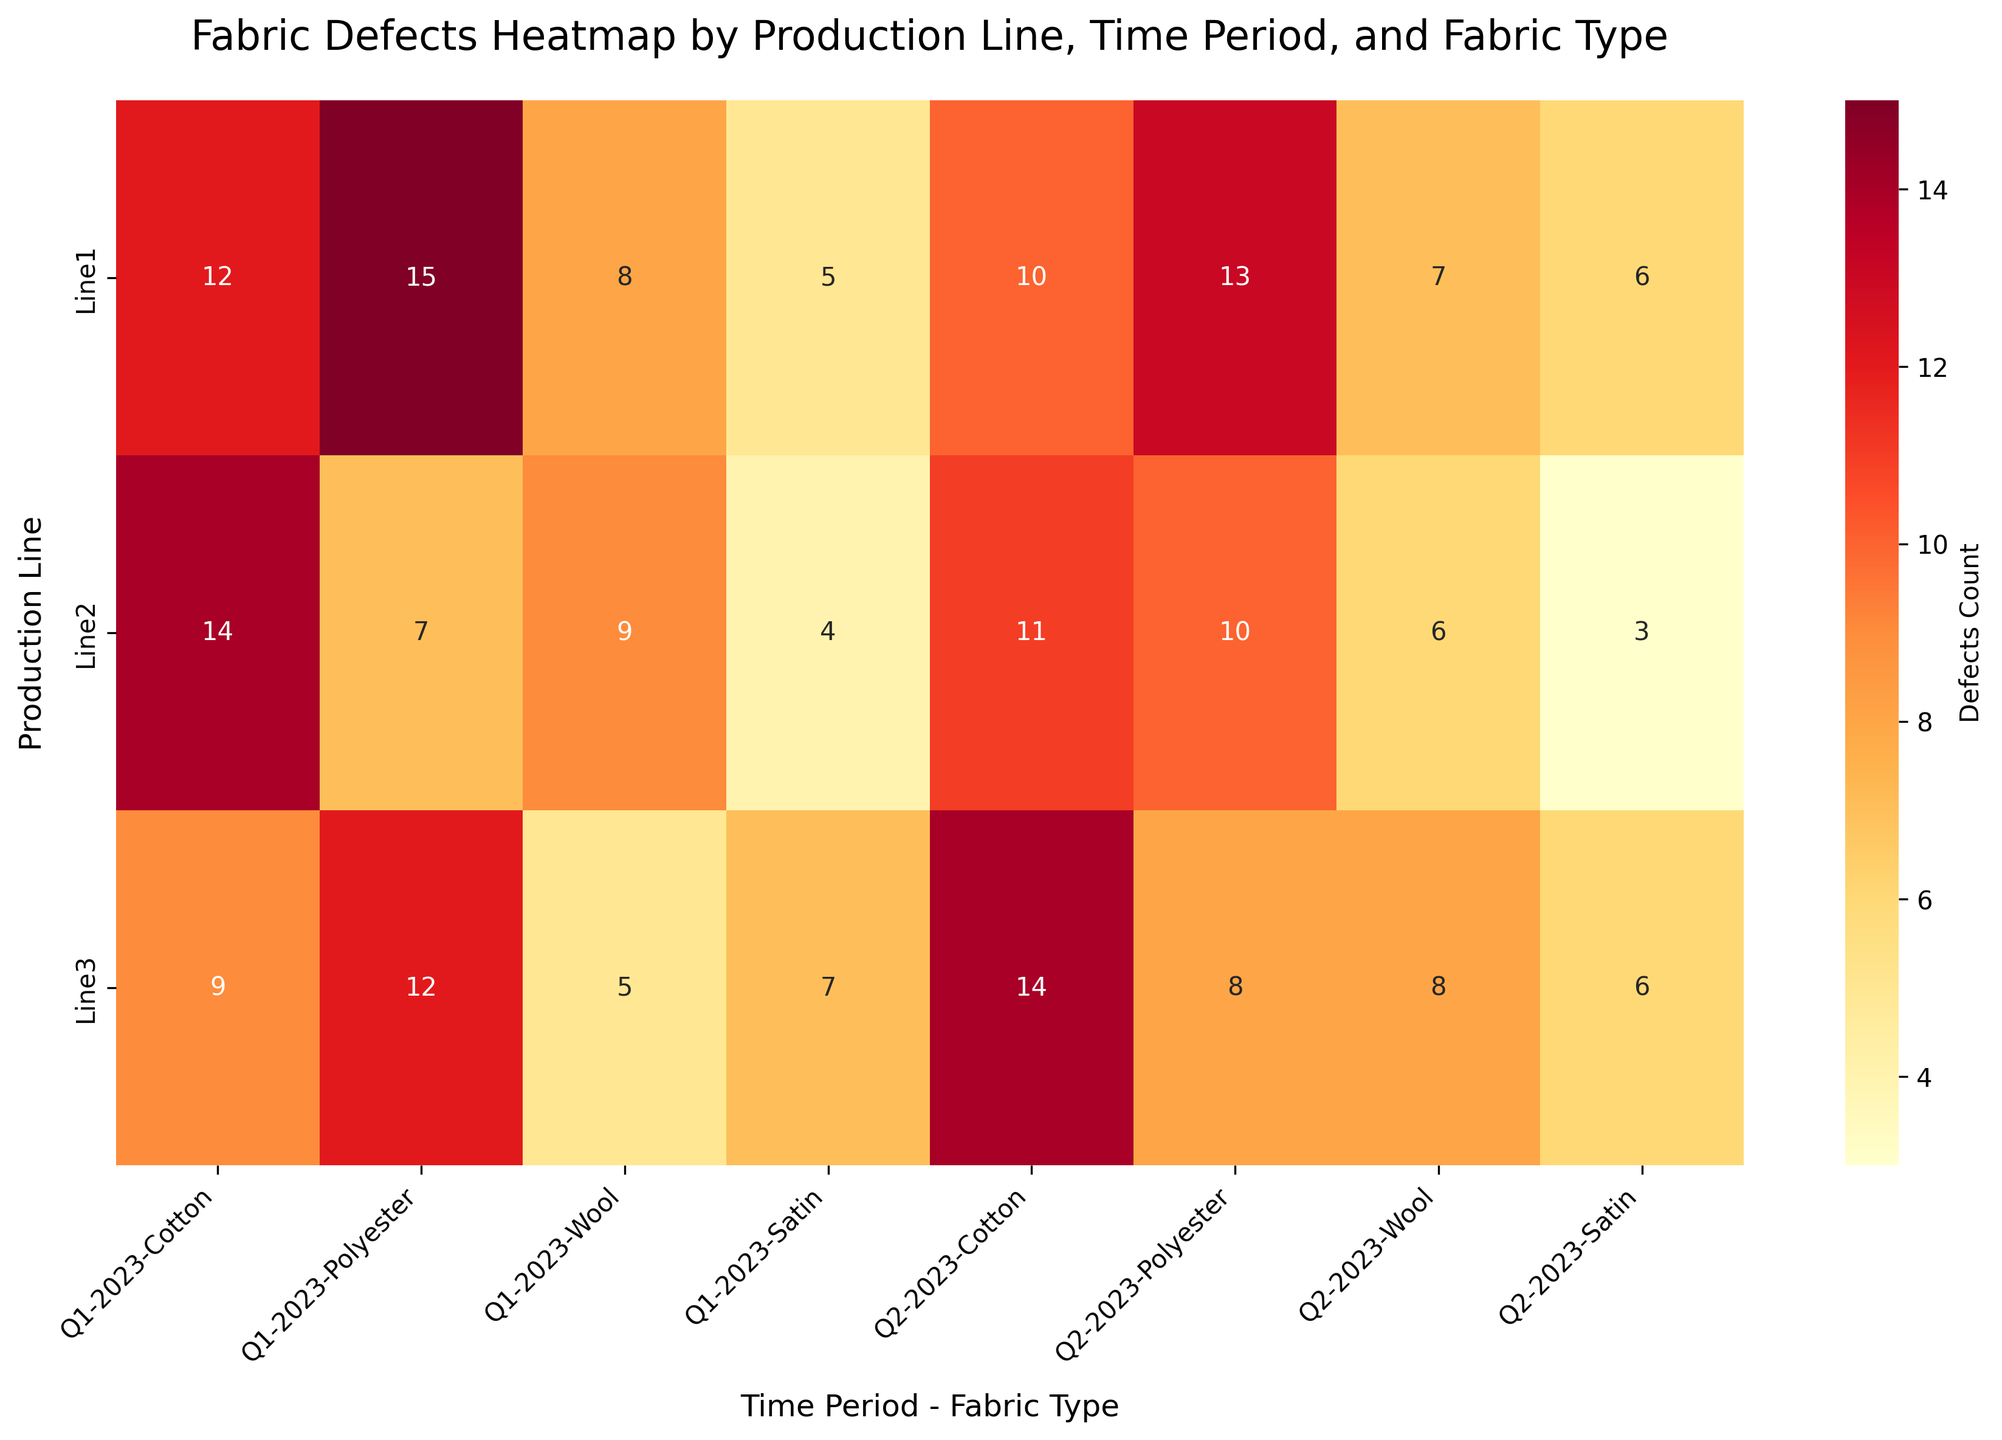What's the title of the heatmap? The title is located at the top of the heatmap and can be easily read from the figure.
Answer: Fabric Defects Heatmap by Production Line, Time Period, and Fabric Type How many fabric types are displayed in each time period? By examining the labels on the x-axis, we can count the distinct fabric types listed under each time period.
Answer: Four (Cotton, Polyester, Wool, Satin) Which production line had the highest number of defects for Polyester in Q1-2023? Identify the intersection of 'Polyester' and 'Q1-2023' for each production line and find the highest value among them.
Answer: Line1 What's the sum of defects for all types of fabrics in Line2 during Q2-2023? Add up the defect counts for 'Cotton', 'Polyester', 'Wool', and 'Satin' in Line2 during Q2-2023. The values are 11, 10, 6, and 3 respectively.
Answer: Sum = 11 + 10 + 6 + 3 = 30 What is the average count of defects for Cotton across all production lines in Q2-2023? Calculate the average by summing the defect counts for 'Cotton' across all lines in Q2-2023 (10+11+14) and dividing by the number of lines (3).
Answer: Average = (10 + 11 + 14) / 3 = 11.67 In which quarter did Line3 experience the highest total number of defects across all fabric types? Sum the defects for each fabric type in both Q1-2023 and Q2-2023 for Line3 and compare the totals. Q1-2023: 9+12+5+7=33, Q2-2023: 14+8+8+6=36. Q2-2023 is higher.
Answer: Q2-2023 Which time period and fabric type combination had no defects reported? Scan through each cell of the heatmap to check if there are any cells with a defect count of zero.
Answer: None Is there any instance where Satin had fewer defects than Polyester within the same production line and time period? Compare the defect counts of 'Satin' and 'Polyester' within each production line and time period combination. Yes, for Line3 in Q2-2023, Satin (6) had fewer defects than Polyester (8).
Answer: Yes, Line3 in Q2-2023 How does the defect count of Wool in Line1 compare between Q1-2023 and Q2-2023? Check the defect counts for 'Wool' in Line1 for Q1-2023 and Q2-2023 and note the difference. Q1-2023: 8, Q2-2023: 7.
Answer: Wool defects decreased by 1 What is the difference in the total defect count between Line1 and Line3 during Q1-2023? First, sum the defect counts for all fabric types in Line1 and Line3 during Q1-2023, then find the difference. Line1: 12+15+8+5=40, Line3: 9+12+5+7=33, Difference: 40-33=7.
Answer: Difference = 7 